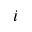Convert formula to latex. <formula><loc_0><loc_0><loc_500><loc_500>i</formula> 